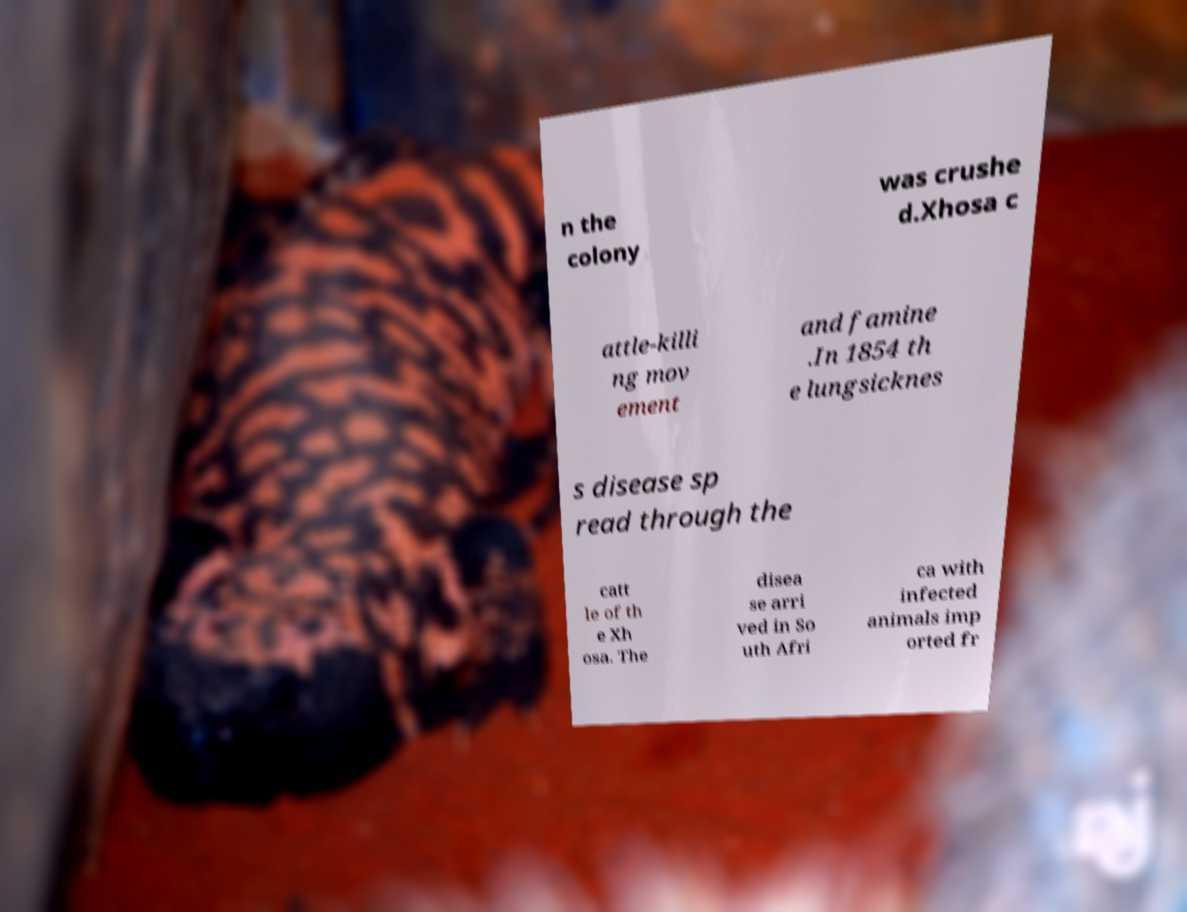Can you read and provide the text displayed in the image?This photo seems to have some interesting text. Can you extract and type it out for me? n the colony was crushe d.Xhosa c attle-killi ng mov ement and famine .In 1854 th e lungsicknes s disease sp read through the catt le of th e Xh osa. The disea se arri ved in So uth Afri ca with infected animals imp orted fr 